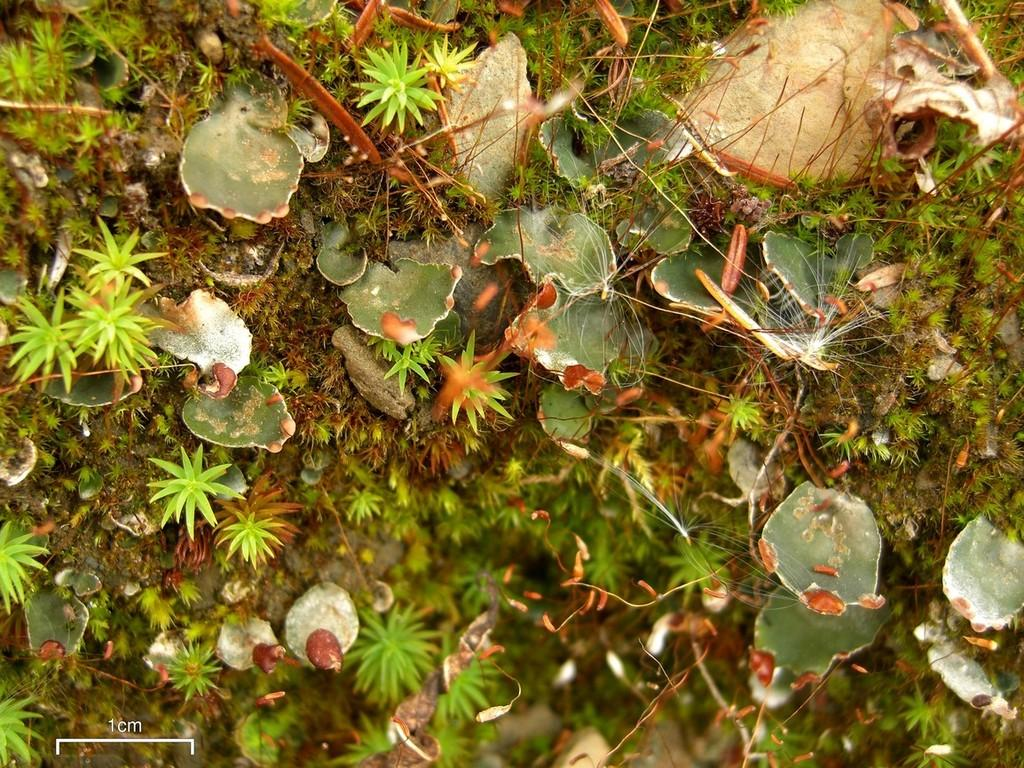What type of vegetation is present on the ground in the image? There are plants on the ground in the image. Can you describe the quality of the image at the bottom? The bottom of the image is blurry. What type of polish is being applied to the glass in the image? There is no glass or polish present in the image; it only features plants on the ground. 